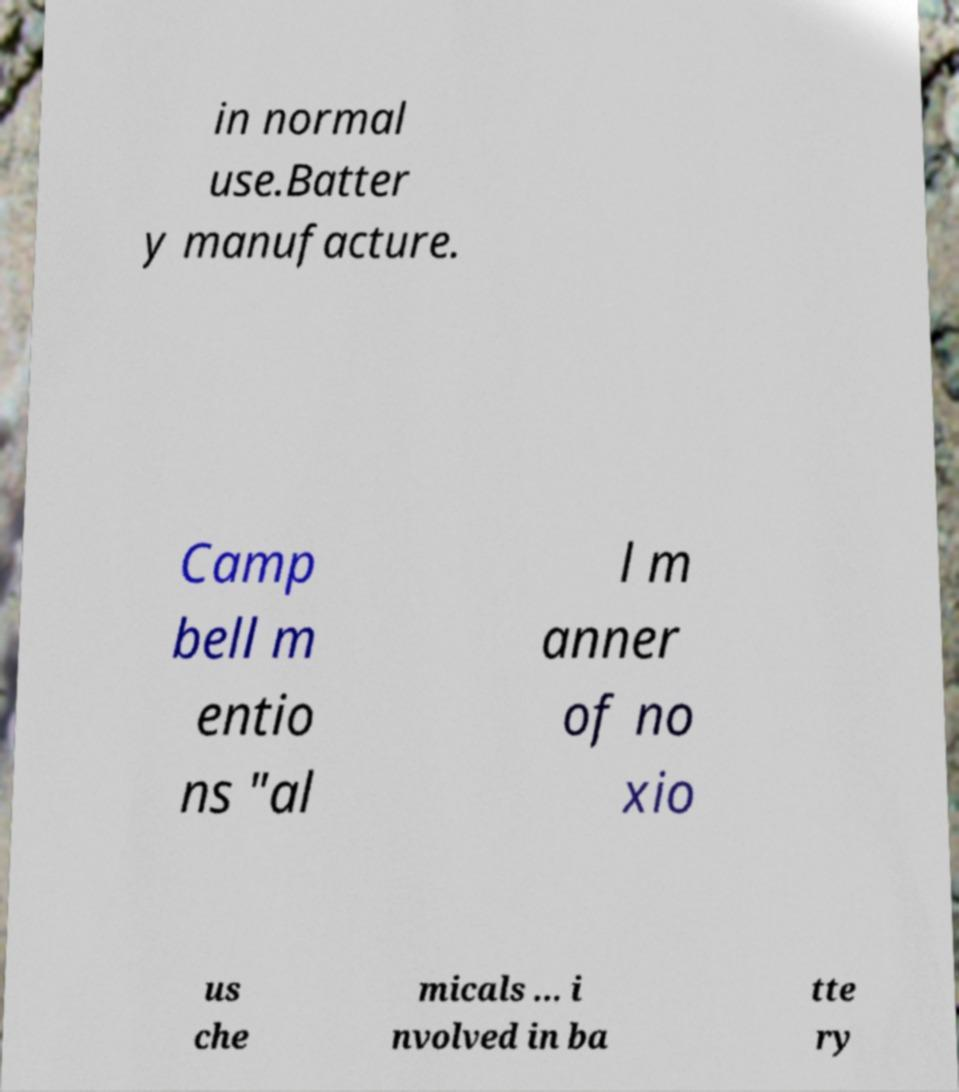There's text embedded in this image that I need extracted. Can you transcribe it verbatim? in normal use.Batter y manufacture. Camp bell m entio ns "al l m anner of no xio us che micals ... i nvolved in ba tte ry 